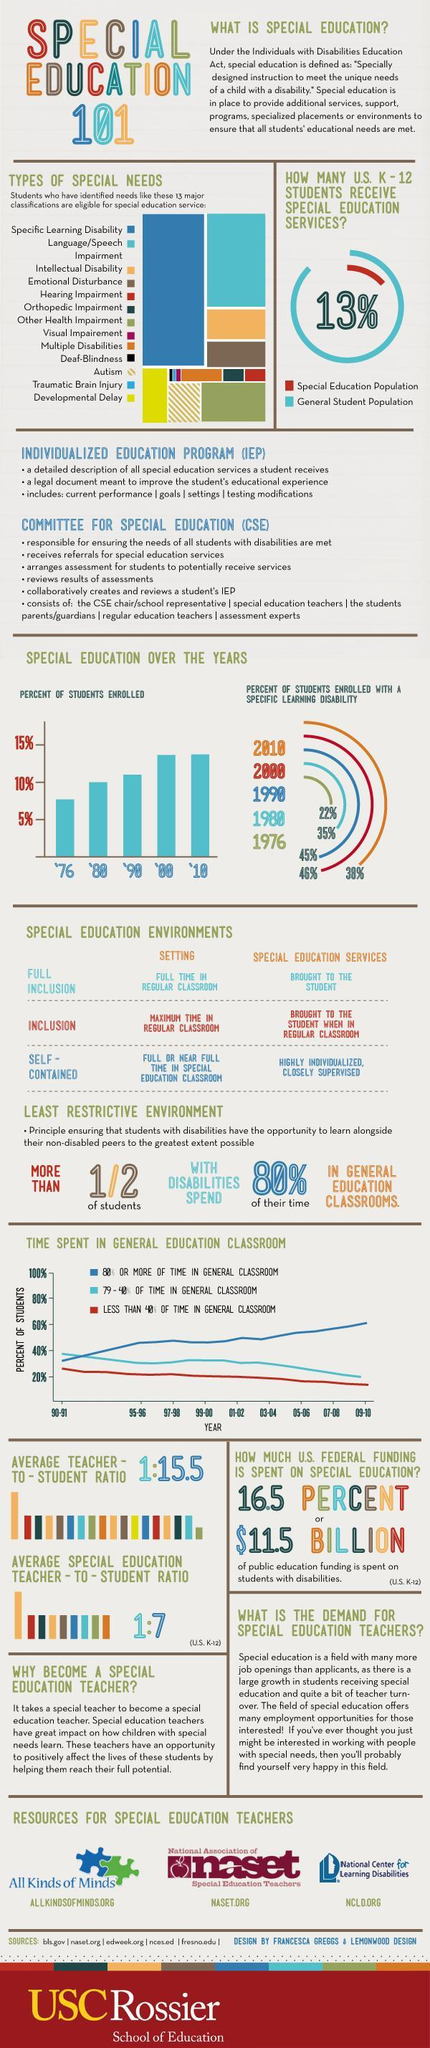Which all years the same percentage of students enrolled?
Answer the question with a short phrase. '00, '10 What percentage of students enrolled in '76? 5.5% 